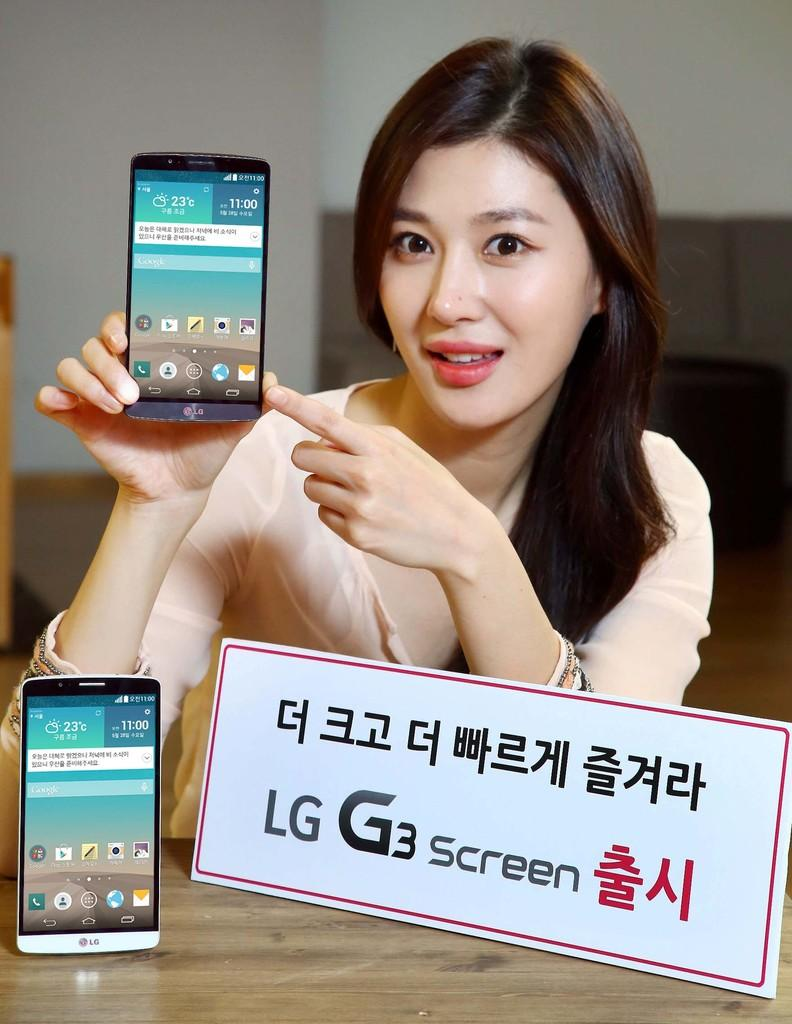<image>
Describe the image concisely. Lady is holding a phone in her hand that is a LG G3 screen 